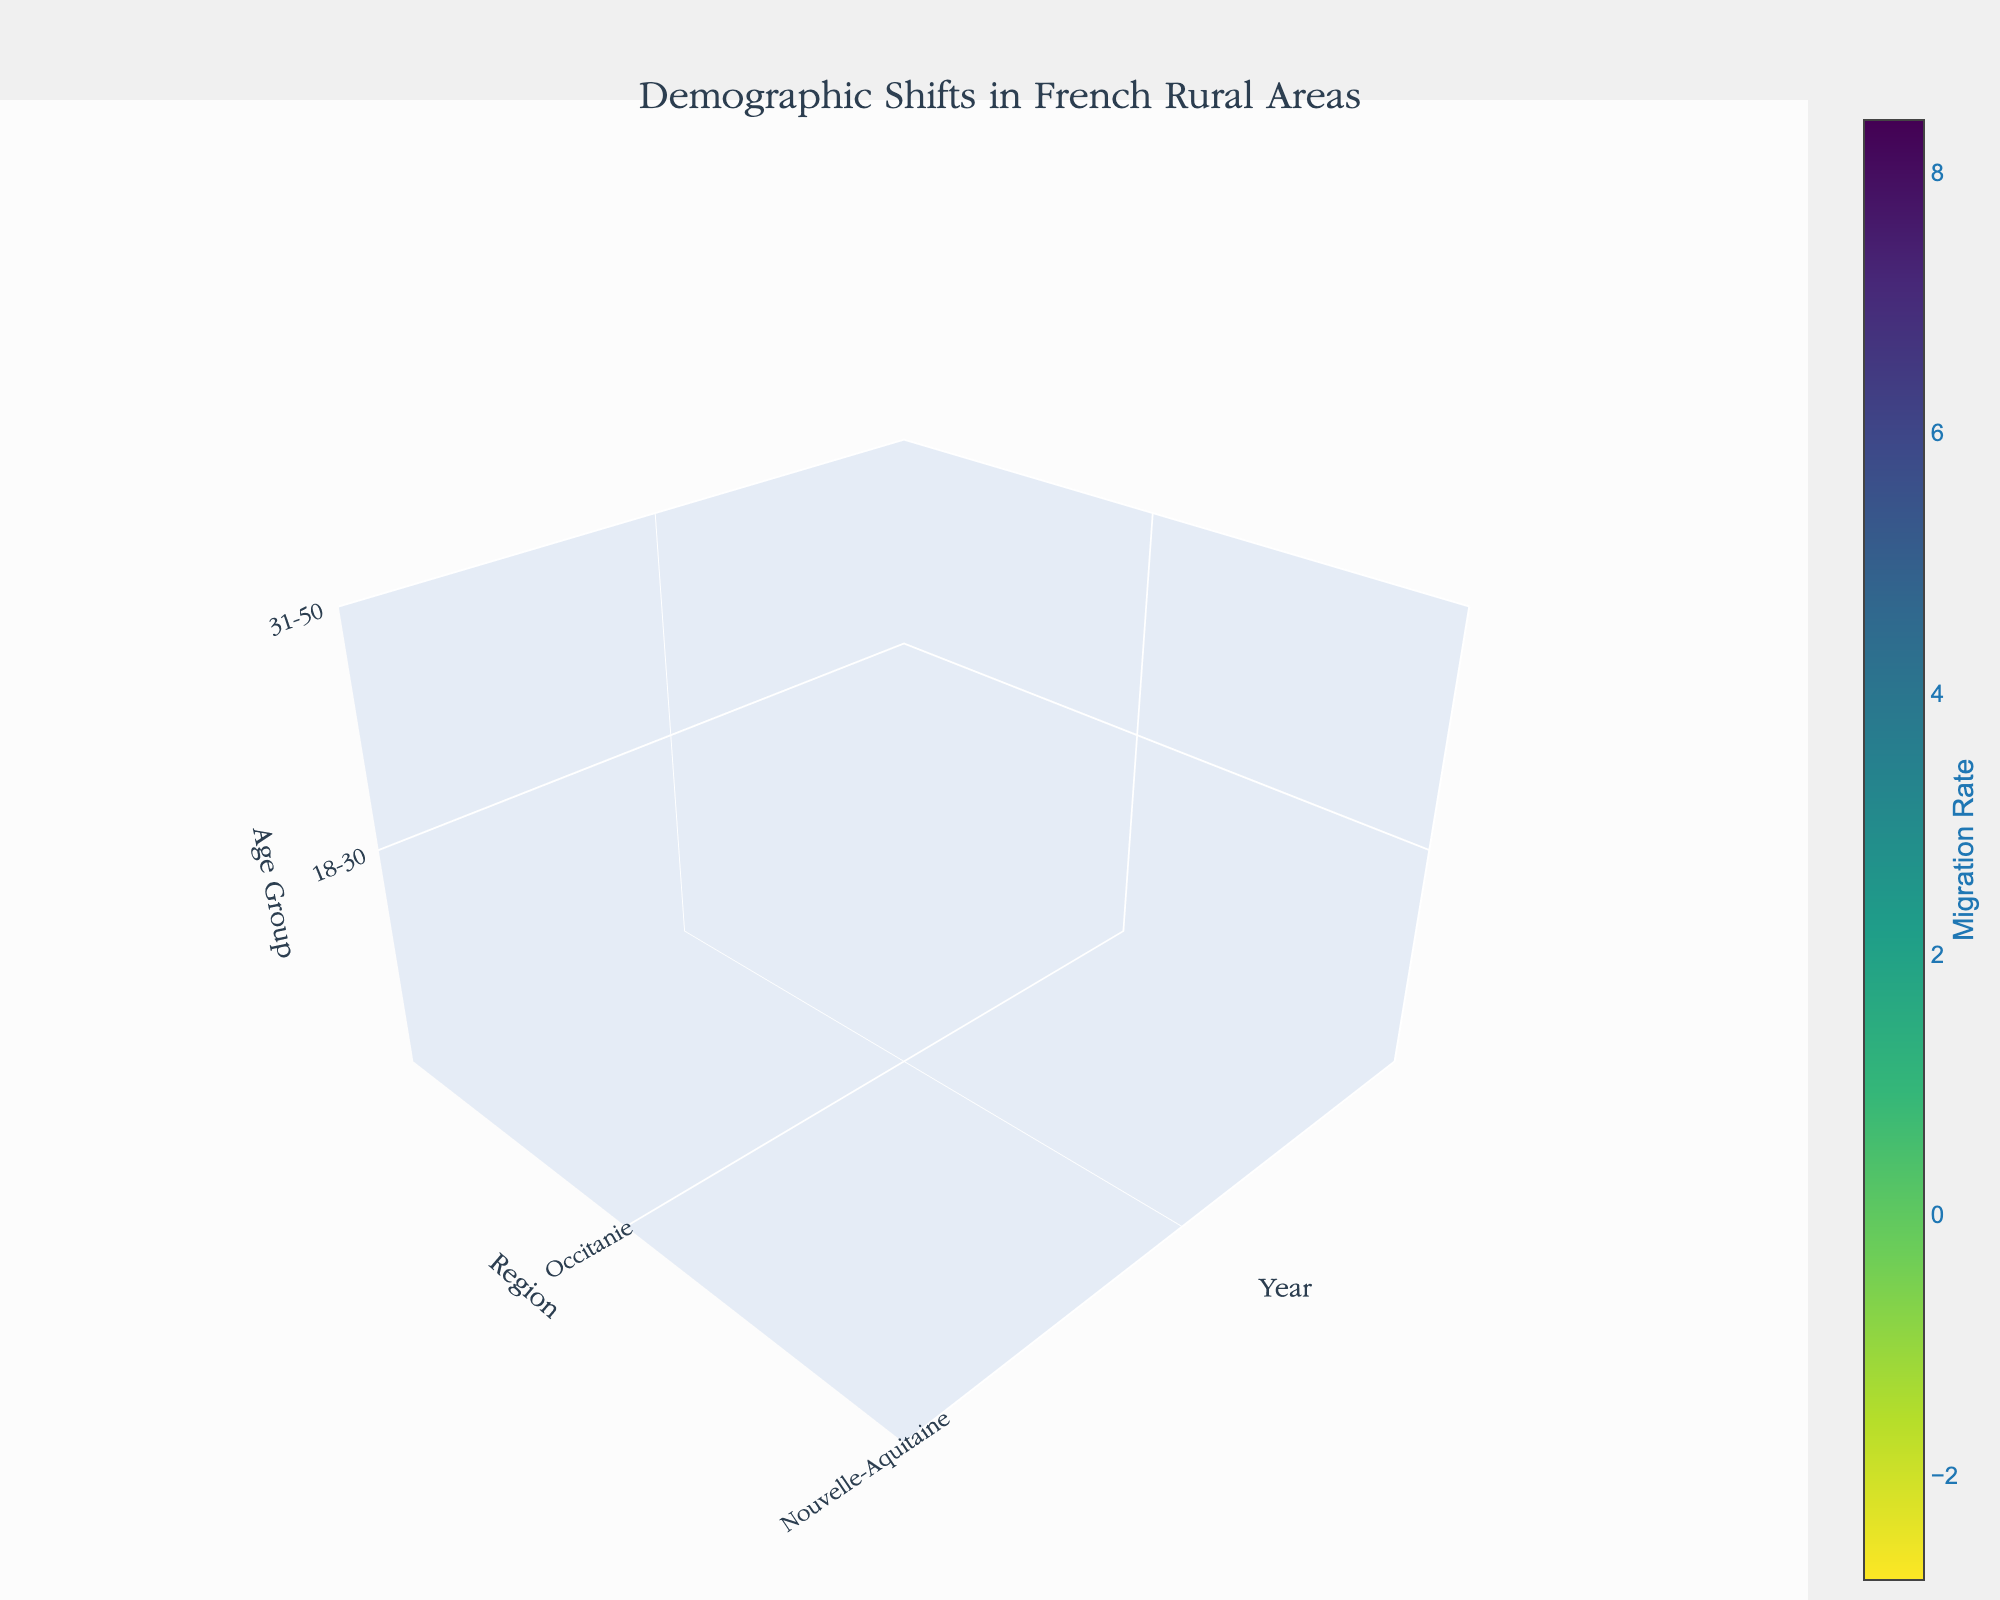what is the title of the plot? The title of the plot is centered at the top of the figure in bold text and larger font size, which reads "Demographic Shifts in French Rural Areas".
Answer: Demographic Shifts in French Rural Areas what does the color scale represent in the plot? The color scale is displayed on the right side of the plot with a color bar labeled "Migration Rate". It indicates the migration rates with colors ranging from purple to yellow, with different intensities signifying different values.
Answer: Migration Rate which age group in Occitanie had the highest migration rate in 2020? To determine this, locate the region 'Occitanie' on the Y-axis, the year '2020' on the X-axis, and find the age group with the highest value on the color scale. For 2020, the age group 18-30 shows the most intense color, indicating the highest migration rate.
Answer: 18-30 how did the migration rate for the 31-50 age group in Nouvelle-Aquitaine change between 2010 and 2020? This requires tracking the values for 31-50 age group in Nouvelle-Aquitaine from 2010 to 2020. The migration rate increased from 3.3 in 2010 to 4.9 in 2020, showing a steady rise.
Answer: Increased which region had the least negative migration rate for the 65+ age group in 2010? Compare the migration rates for each region for the 65+ age group in 2010. Occitanie had a rate of -2.5, Nouvelle-Aquitaine -2.8, and Auvergne-Rhône-Alpes -2.3. Auvergne-Rhône-Alpes, with -2.3, is the least negative.
Answer: Auvergne-Rhône-Alpes what general trend is observed in migration rates for younger age groups (18-30, 31-50) across all regions from 2010 to 2020? Observing the migration rates for age groups 18-30 and 31-50 in all regions across the years 2010, 2015, and 2020 shows overall increasing migration rates, signifying a positive trend among these younger age groups.
Answer: Increasing which region shows the most significant decrease in migration rate for the 51-65 age group from 2010 to 2020? Compare the changes in migration rates for the 51-65 age group across regions. Occitanie (-1.2 to -0.3), Nouvelle-Aquitaine (-1.5 to -0.6), and Auvergne-Rhône-Alpes (-1.0 to -0.1) all show increases, no region has a decreasing trend for this group.
Answer: None what is the overall migration pattern for the 65+ age group across all regions? By examining all regions for the 65+ age group's data points from 2010 to 2020, one can see relatively negative migration rates, but the negativity decreases over time, indicating that the migration rates are becoming less negative.
Answer: Decreasing in negativity how does the migration rate in Occitanie in 2015 for the age groups 18-30 and 31-50 compare to each other? Compare the migration rates explicitly for the age groups 18-30 and 31-50 in Occitanie for the year 2015. The rate for 18-30 is 6.8, and for 31-50, it is 4.5. The 18-30 age group has a higher rate.
Answer: Higher for 18-30 